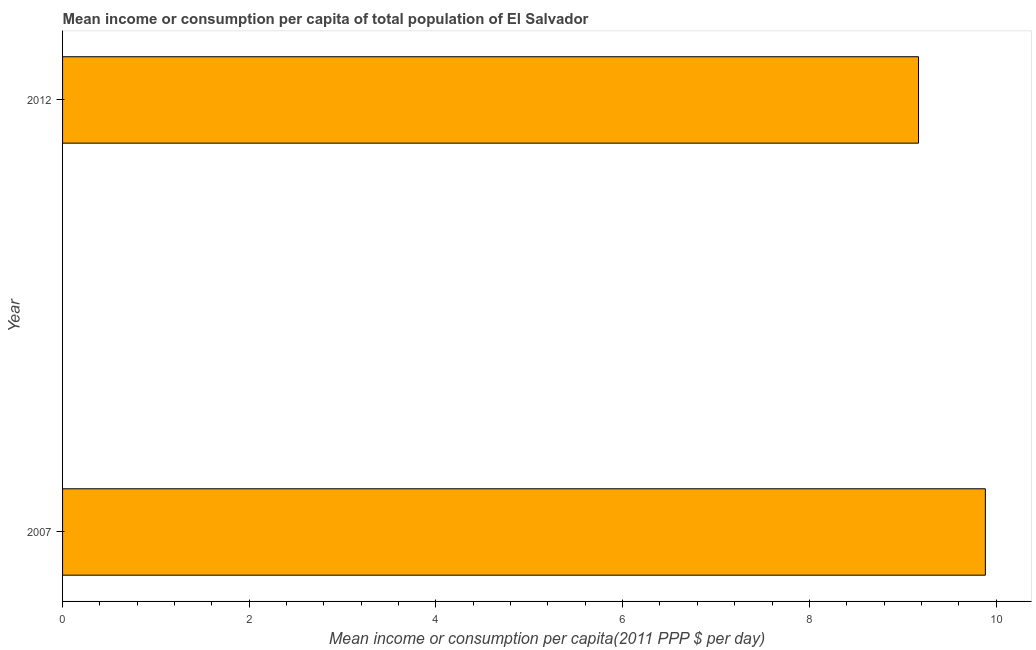Does the graph contain any zero values?
Your answer should be compact. No. What is the title of the graph?
Your answer should be compact. Mean income or consumption per capita of total population of El Salvador. What is the label or title of the X-axis?
Your response must be concise. Mean income or consumption per capita(2011 PPP $ per day). What is the mean income or consumption in 2012?
Provide a short and direct response. 9.17. Across all years, what is the maximum mean income or consumption?
Offer a very short reply. 9.89. Across all years, what is the minimum mean income or consumption?
Your answer should be very brief. 9.17. In which year was the mean income or consumption minimum?
Offer a very short reply. 2012. What is the sum of the mean income or consumption?
Your answer should be compact. 19.06. What is the difference between the mean income or consumption in 2007 and 2012?
Keep it short and to the point. 0.72. What is the average mean income or consumption per year?
Provide a short and direct response. 9.53. What is the median mean income or consumption?
Provide a succinct answer. 9.53. In how many years, is the mean income or consumption greater than 8.4 $?
Your response must be concise. 2. Do a majority of the years between 2007 and 2012 (inclusive) have mean income or consumption greater than 4.4 $?
Offer a very short reply. Yes. What is the ratio of the mean income or consumption in 2007 to that in 2012?
Your answer should be very brief. 1.08. Is the mean income or consumption in 2007 less than that in 2012?
Ensure brevity in your answer.  No. In how many years, is the mean income or consumption greater than the average mean income or consumption taken over all years?
Ensure brevity in your answer.  1. Are all the bars in the graph horizontal?
Keep it short and to the point. Yes. What is the difference between two consecutive major ticks on the X-axis?
Give a very brief answer. 2. Are the values on the major ticks of X-axis written in scientific E-notation?
Your answer should be very brief. No. What is the Mean income or consumption per capita(2011 PPP $ per day) of 2007?
Make the answer very short. 9.89. What is the Mean income or consumption per capita(2011 PPP $ per day) in 2012?
Offer a very short reply. 9.17. What is the difference between the Mean income or consumption per capita(2011 PPP $ per day) in 2007 and 2012?
Your answer should be compact. 0.72. What is the ratio of the Mean income or consumption per capita(2011 PPP $ per day) in 2007 to that in 2012?
Provide a short and direct response. 1.08. 